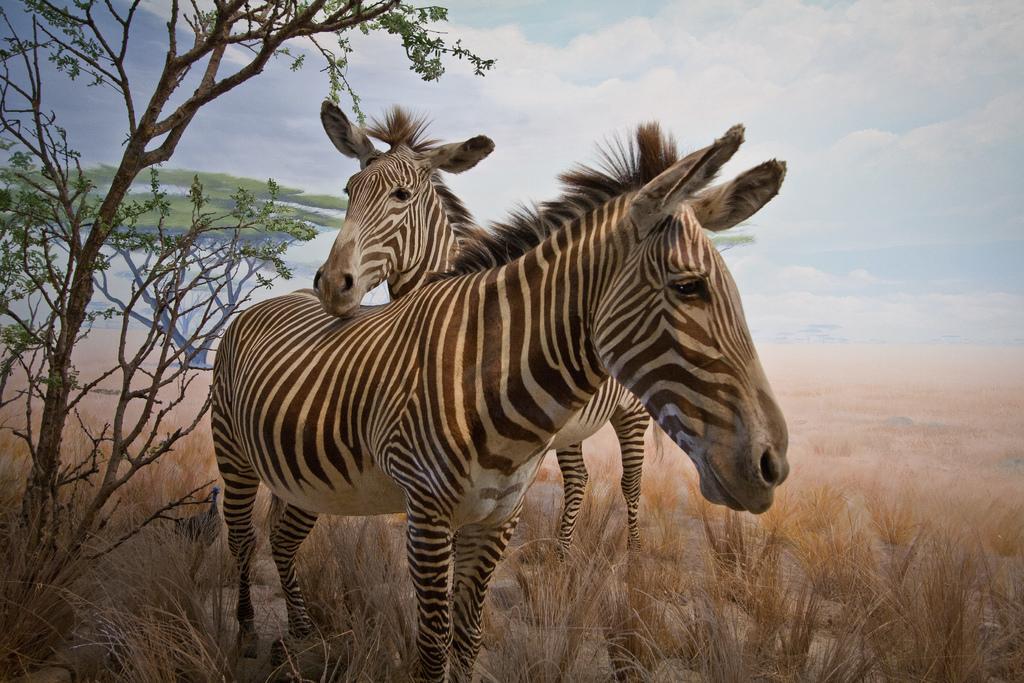Describe this image in one or two sentences. In this image there is the sky, there are clouds in the sky, there are trees, there is a tree truncated towards the left of the image, there are grass, there are zebras. 